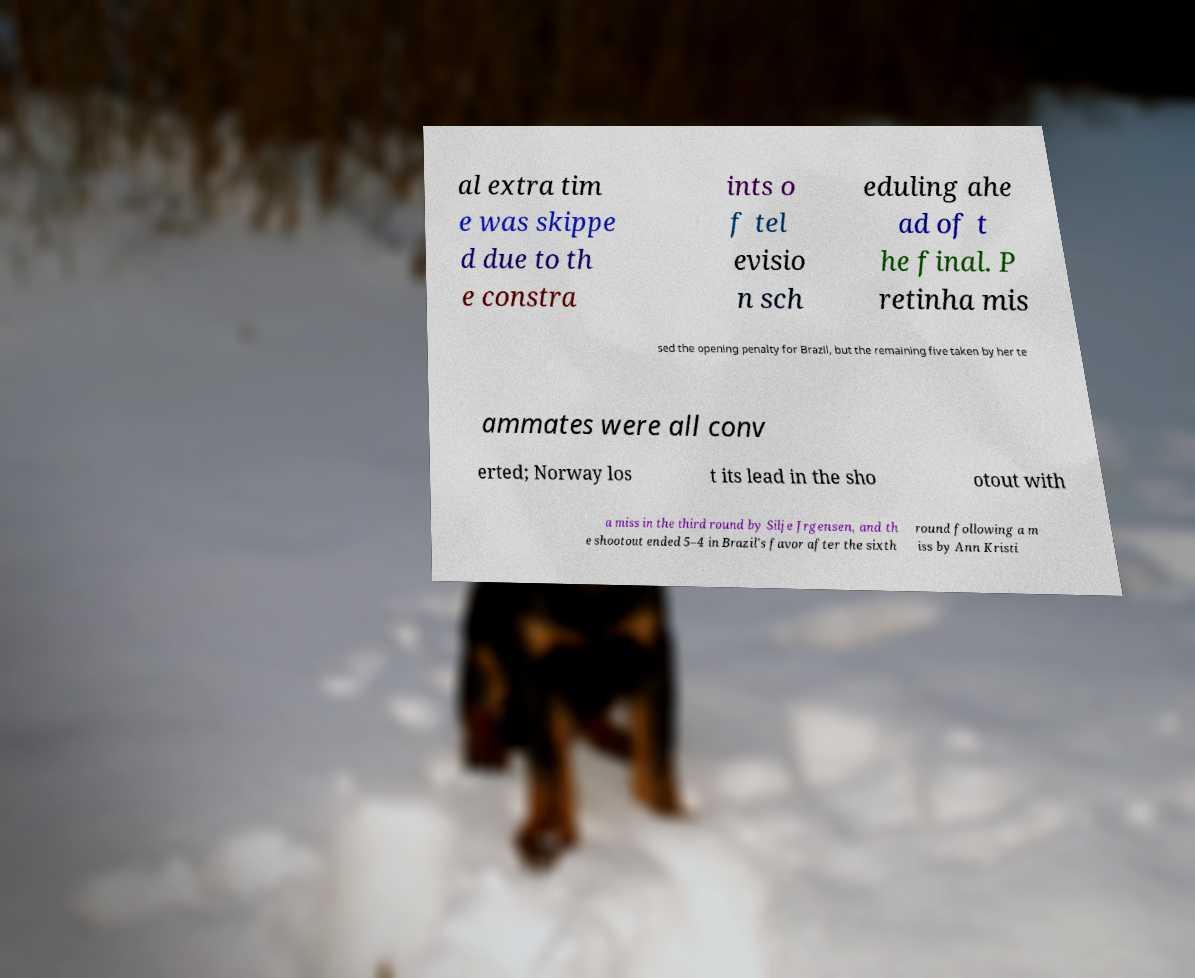For documentation purposes, I need the text within this image transcribed. Could you provide that? al extra tim e was skippe d due to th e constra ints o f tel evisio n sch eduling ahe ad of t he final. P retinha mis sed the opening penalty for Brazil, but the remaining five taken by her te ammates were all conv erted; Norway los t its lead in the sho otout with a miss in the third round by Silje Jrgensen, and th e shootout ended 5–4 in Brazil's favor after the sixth round following a m iss by Ann Kristi 